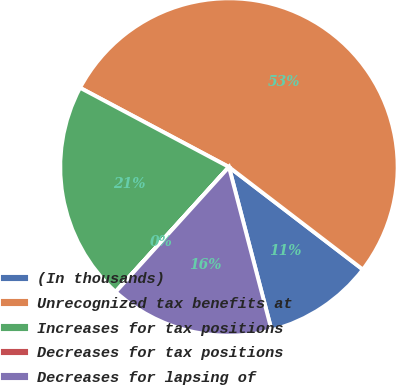Convert chart. <chart><loc_0><loc_0><loc_500><loc_500><pie_chart><fcel>(In thousands)<fcel>Unrecognized tax benefits at<fcel>Increases for tax positions<fcel>Decreases for tax positions<fcel>Decreases for lapsing of<nl><fcel>10.53%<fcel>52.62%<fcel>21.05%<fcel>0.01%<fcel>15.79%<nl></chart> 